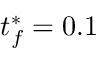<formula> <loc_0><loc_0><loc_500><loc_500>t _ { f } ^ { \ast } = 0 . 1</formula> 